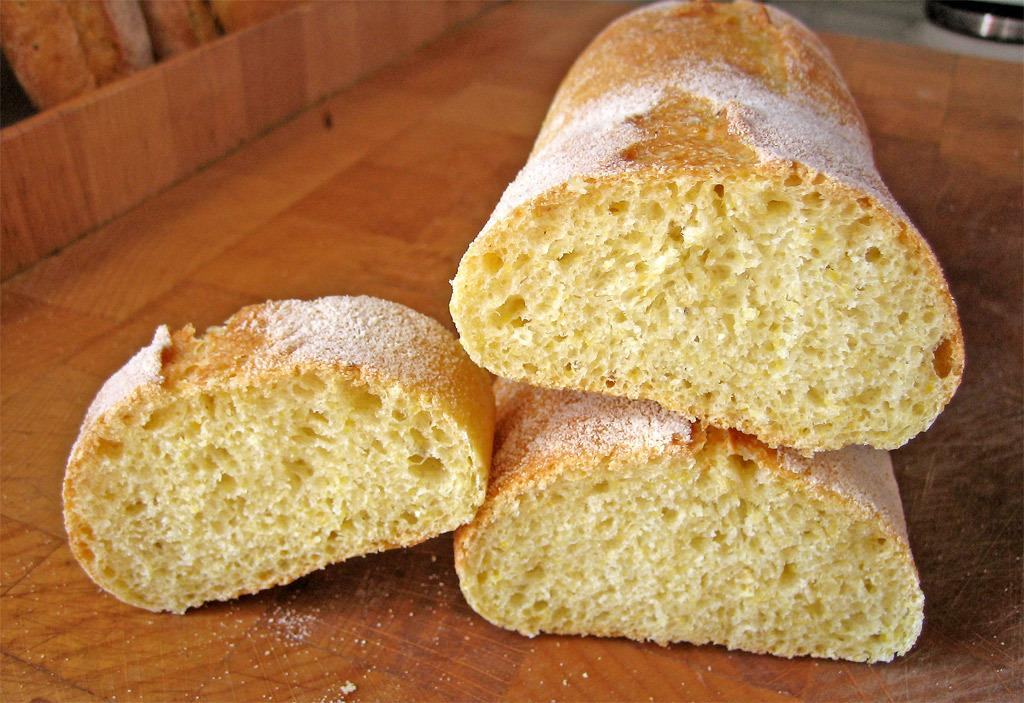What types of items can be seen in the image? There are food items in the image. What is the food placed on or near? The food items are on a wooden object. What type of thumb can be seen interacting with the food in the image? There is no thumb present in the image; it only shows food items on a wooden object. What kind of sea creatures are swimming in the image? There is no sea or sea creatures present in the image; it only shows food items on a wooden object. 